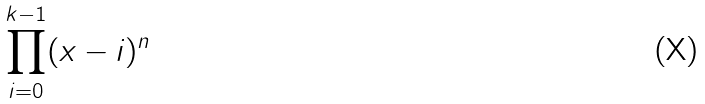Convert formula to latex. <formula><loc_0><loc_0><loc_500><loc_500>\prod _ { i = 0 } ^ { k - 1 } ( x - i ) ^ { n }</formula> 